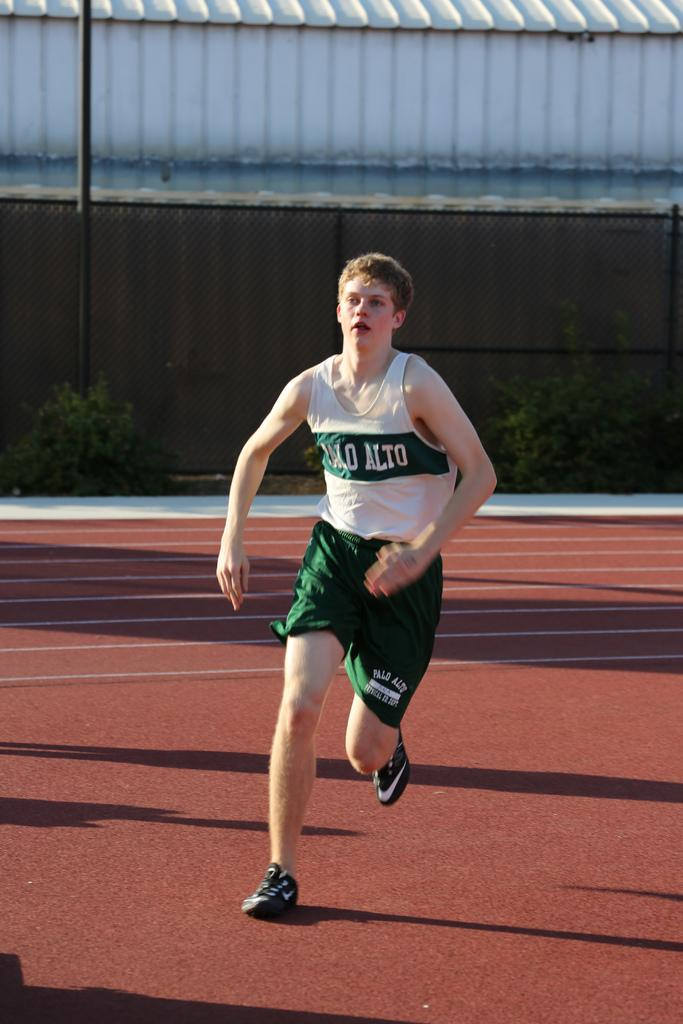Provide a one-sentence caption for the provided image. A young man runs on a track wearing a Palo Alto vest. 